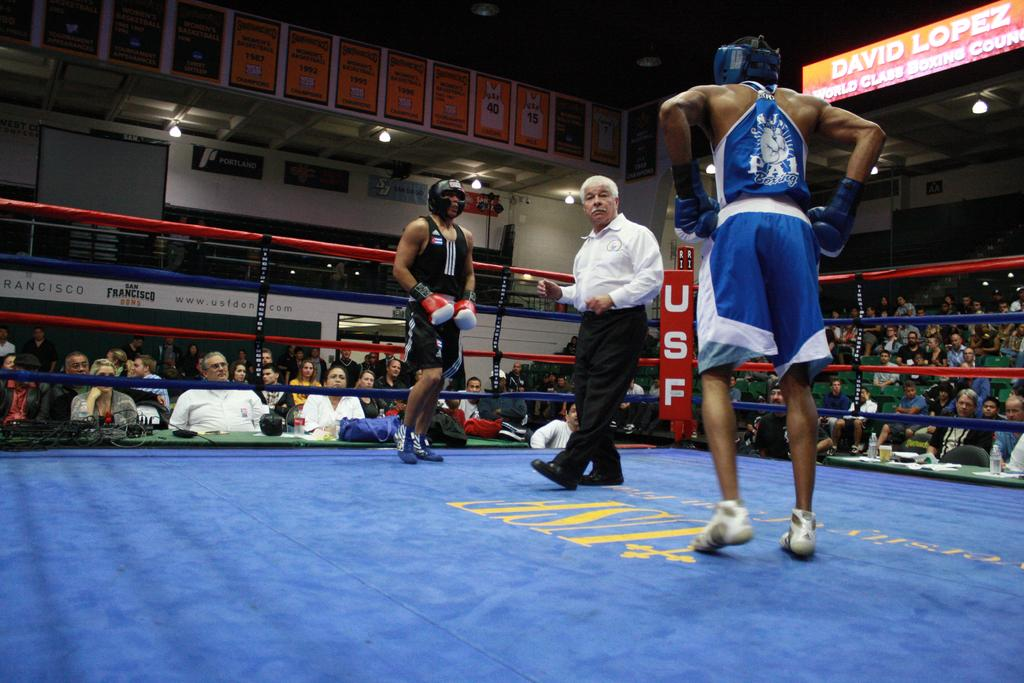Provide a one-sentence caption for the provided image. A sign above the seating area shows one of the competitors is David Lopez. 